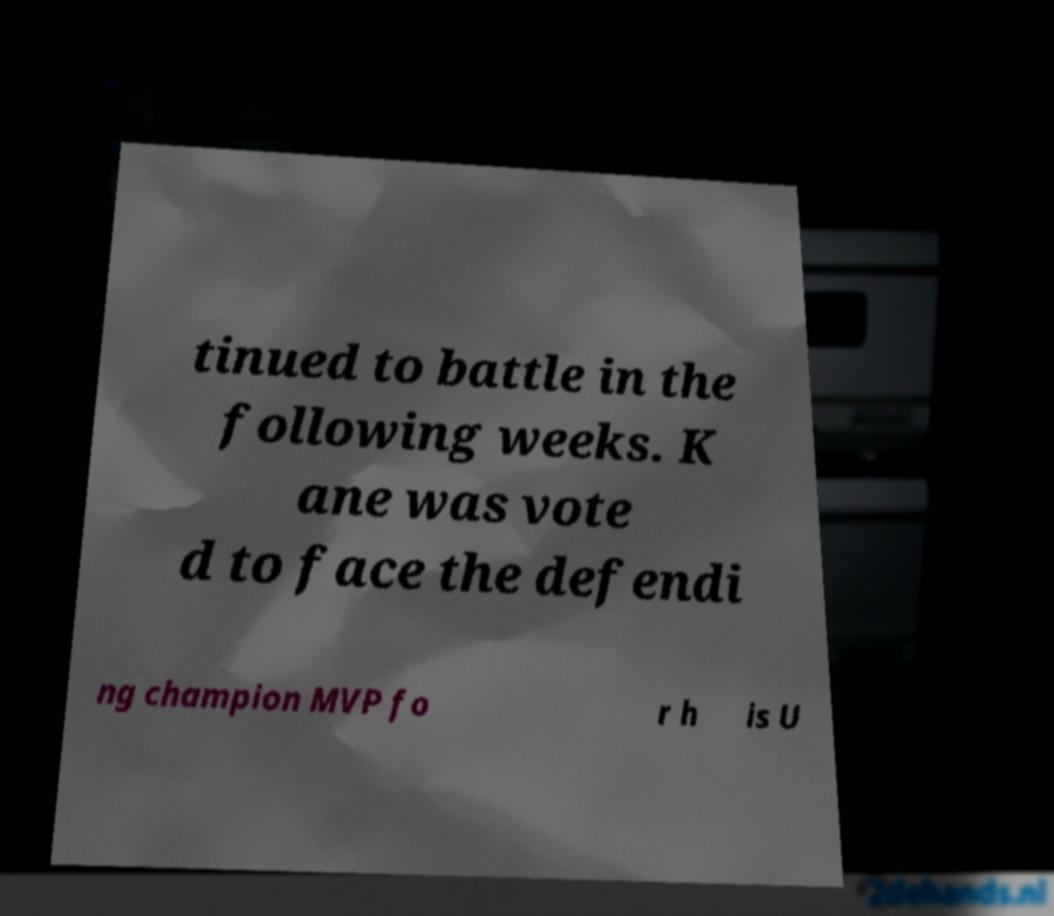I need the written content from this picture converted into text. Can you do that? tinued to battle in the following weeks. K ane was vote d to face the defendi ng champion MVP fo r h is U 